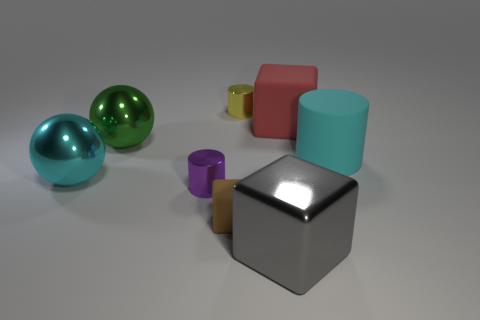How many objects are either matte cubes that are on the right side of the yellow cylinder or purple cylinders in front of the yellow metallic cylinder?
Provide a short and direct response. 2. There is a cube that is the same size as the purple metallic thing; what is it made of?
Make the answer very short. Rubber. The big rubber cube is what color?
Your response must be concise. Red. There is a block that is both right of the yellow metallic thing and in front of the green sphere; what is it made of?
Offer a very short reply. Metal. Is there a metallic block on the left side of the metallic cylinder that is behind the large metallic object that is behind the big cyan shiny sphere?
Provide a short and direct response. No. The metal object that is the same color as the matte cylinder is what size?
Ensure brevity in your answer.  Large. Are there any brown rubber cubes right of the tiny brown matte cube?
Give a very brief answer. No. How many other things are the same shape as the green thing?
Offer a terse response. 1. The metallic cube that is the same size as the red object is what color?
Your answer should be compact. Gray. Are there fewer big green objects that are in front of the brown rubber thing than cyan objects that are right of the green metallic object?
Keep it short and to the point. Yes. 